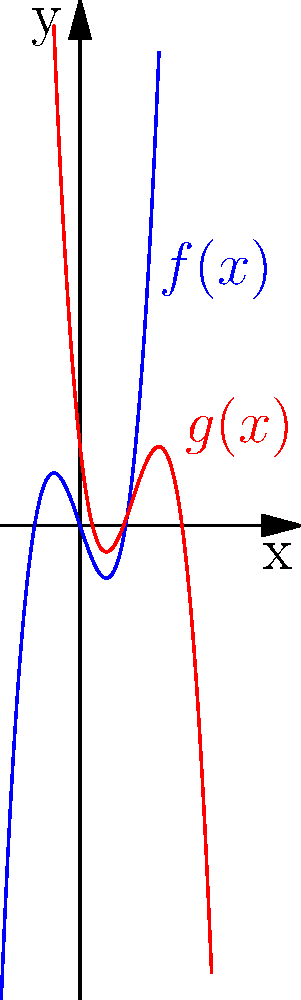As an immigrant who has navigated complex processes, you understand the importance of transformations. Consider the blue graph representing $f(x)=x^3-3x$. The red graph shows a transformation of $f(x)$. Determine the equation of the transformed function $g(x)$ in terms of $f(x)$. Let's approach this step-by-step, similar to how we might break down an immigration process:

1) First, observe the horizontal shift:
   The red graph is shifted 2 units to the right. This means we replace $x$ with $(x-2)$ in the original function.

2) Next, notice the vertical reflection:
   The red graph is a reflection of the blue graph across the x-axis. This is achieved by negating the function, i.e., multiplying by -1.

3) Finally, there's a vertical shift:
   After the reflection, the entire graph is moved up 1 unit.

4) Putting it all together:
   - Start with $f(x)$
   - Replace $x$ with $(x-2)$ for the horizontal shift: $f(x-2)$
   - Negate for the reflection: $-f(x-2)$
   - Add 1 for the vertical shift: $-f(x-2)+1$

Therefore, the equation of $g(x)$ in terms of $f(x)$ is $g(x) = -f(x-2)+1$.

This process of transformation is similar to adapting to a new country - we shift our perspective, sometimes need to "flip" our understanding, and make adjustments to fit into the new system.
Answer: $g(x) = -f(x-2)+1$ 